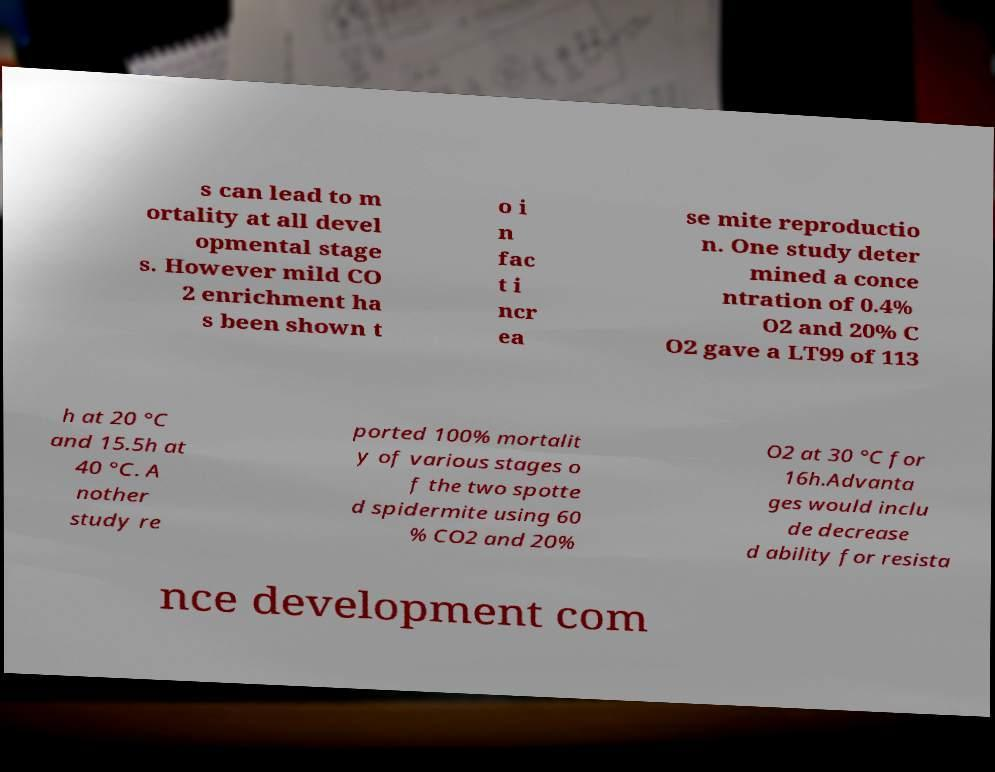Could you assist in decoding the text presented in this image and type it out clearly? s can lead to m ortality at all devel opmental stage s. However mild CO 2 enrichment ha s been shown t o i n fac t i ncr ea se mite reproductio n. One study deter mined a conce ntration of 0.4% O2 and 20% C O2 gave a LT99 of 113 h at 20 °C and 15.5h at 40 °C. A nother study re ported 100% mortalit y of various stages o f the two spotte d spidermite using 60 % CO2 and 20% O2 at 30 °C for 16h.Advanta ges would inclu de decrease d ability for resista nce development com 